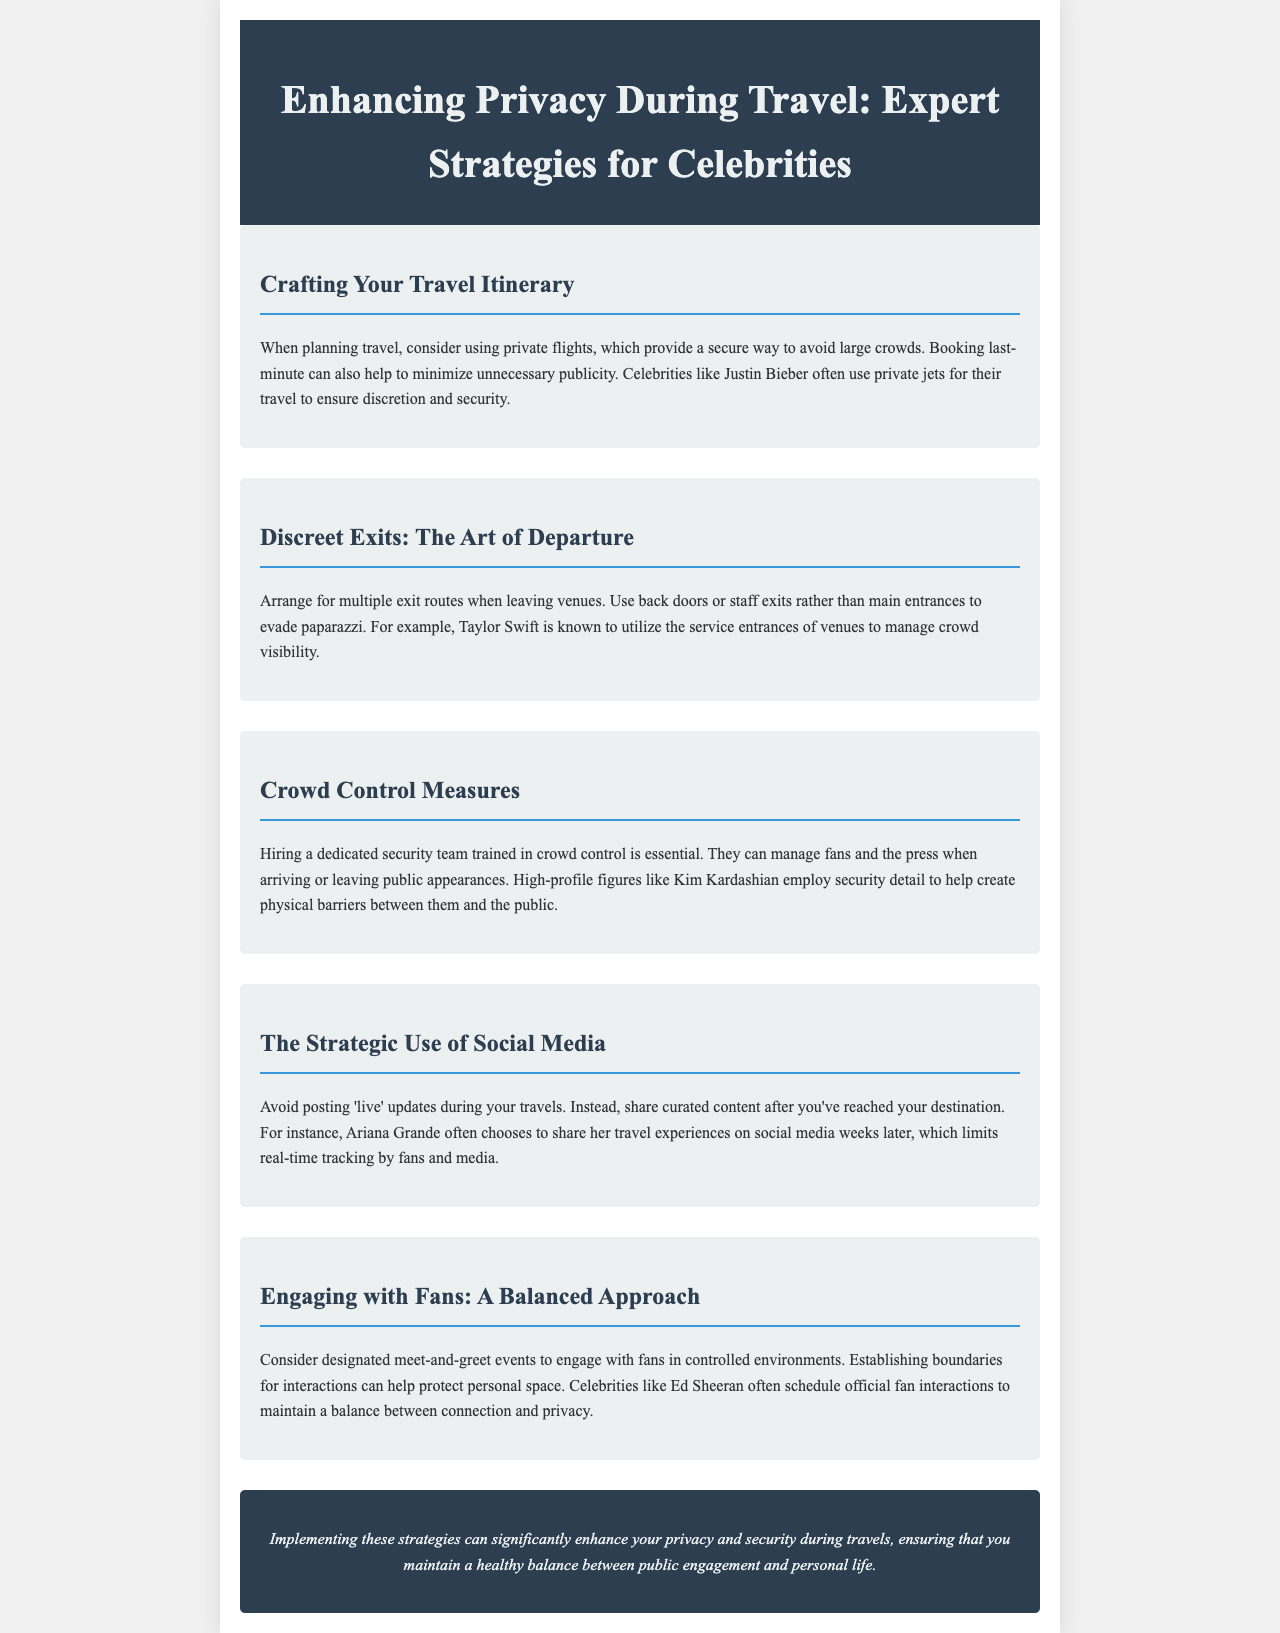what is a suggested transportation method for celebrities? The document recommends using private flights to avoid large crowds.
Answer: private flights who is mentioned as using service entrances for discreet exits? Taylor Swift is specifically cited as someone who uses service entrances to manage crowd visibility.
Answer: Taylor Swift what is a key strategy for managing crowds during public appearances? Hiring a dedicated security team trained in crowd control is essential for managing crowds.
Answer: dedicated security team what is a recommended approach to social media during travel? The document advises avoiding posting 'live' updates during travels.
Answer: avoid posting 'live' updates who shares travel experiences on social media weeks later? Ariana Grande is noted for sharing her travel experiences after reaching her destination.
Answer: Ariana Grande what is the suggested way to engage with fans? Designated meet-and-greet events are suggested for engaging with fans in controlled environments.
Answer: designated meet-and-greet events how does Kim Kardashian manage crowd control? Kim Kardashian employs a security detail to help create physical barriers between herself and the public.
Answer: security detail what is an effective way for celebrities to balance public engagement and personal life? Establishing boundaries for interactions can help protect personal space.
Answer: establishing boundaries 